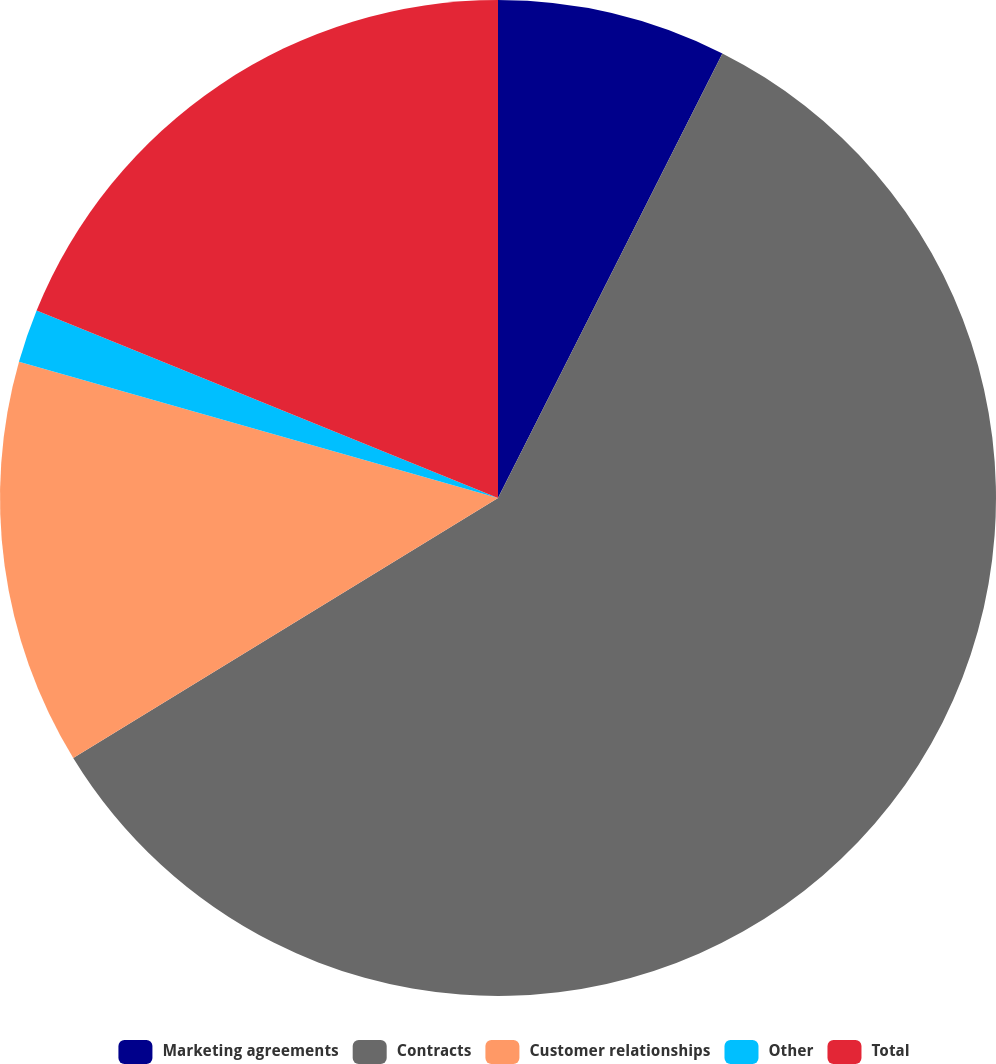Convert chart. <chart><loc_0><loc_0><loc_500><loc_500><pie_chart><fcel>Marketing agreements<fcel>Contracts<fcel>Customer relationships<fcel>Other<fcel>Total<nl><fcel>7.44%<fcel>58.82%<fcel>13.15%<fcel>1.73%<fcel>18.86%<nl></chart> 